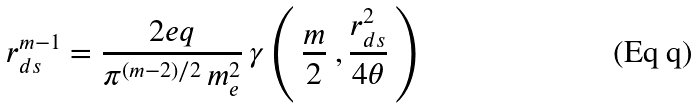Convert formula to latex. <formula><loc_0><loc_0><loc_500><loc_500>r _ { d s } ^ { m - 1 } = \frac { 2 e q } { \pi ^ { ( m - 2 ) / 2 } \, m ^ { 2 } _ { e } } \, \gamma \left ( \, \frac { m } { 2 } \ , \frac { r _ { d s } ^ { 2 } } { 4 \theta } \, \right )</formula> 